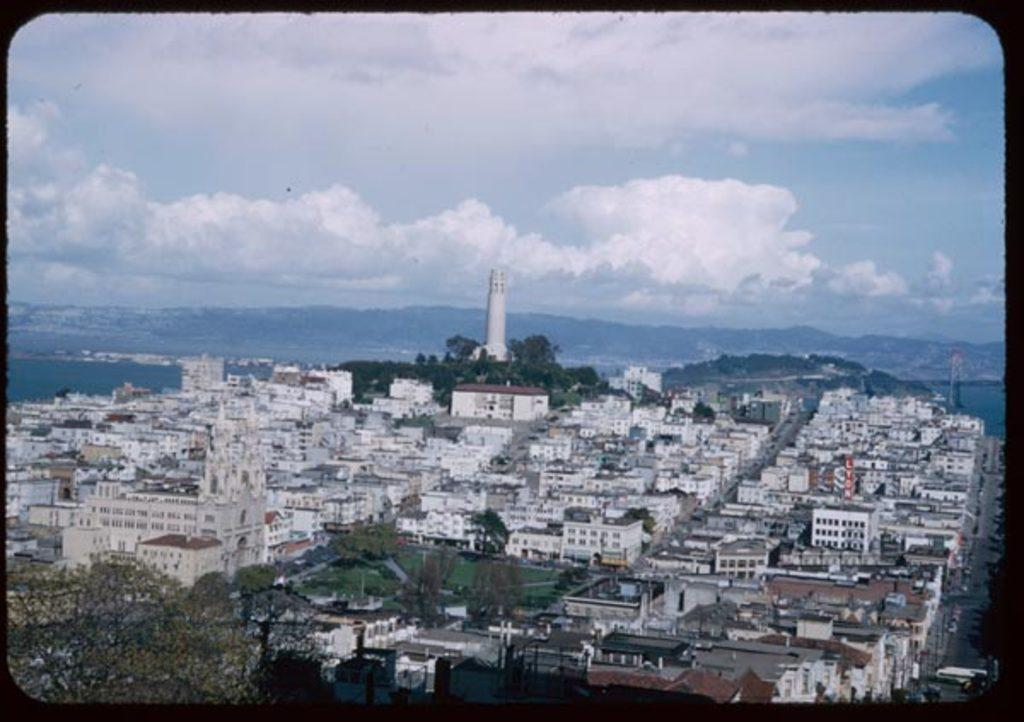What type of structures can be seen in the image? There are buildings in the image. What natural elements are present in the image? There are trees and mountains in the image. What specific feature stands out among the buildings? There is a tower in the image. Where is the scarecrow located in the image? There is no scarecrow present in the image. What type of plant can be seen growing near the trees in the image? There is no specific plant mentioned in the image, only trees are mentioned. 